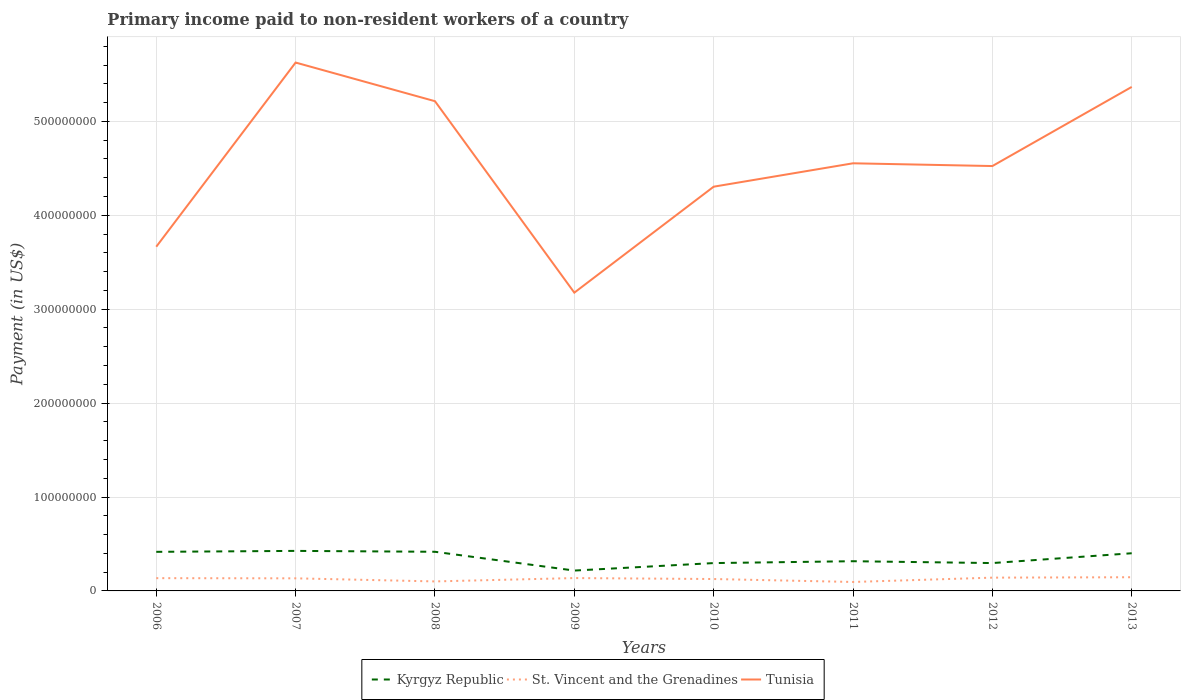How many different coloured lines are there?
Keep it short and to the point. 3. Is the number of lines equal to the number of legend labels?
Your answer should be very brief. Yes. Across all years, what is the maximum amount paid to workers in Tunisia?
Keep it short and to the point. 3.18e+08. What is the total amount paid to workers in Kyrgyz Republic in the graph?
Offer a very short reply. -1.44e+04. What is the difference between the highest and the second highest amount paid to workers in St. Vincent and the Grenadines?
Provide a short and direct response. 5.05e+06. Is the amount paid to workers in Tunisia strictly greater than the amount paid to workers in Kyrgyz Republic over the years?
Offer a terse response. No. How many lines are there?
Ensure brevity in your answer.  3. How many years are there in the graph?
Provide a short and direct response. 8. Are the values on the major ticks of Y-axis written in scientific E-notation?
Provide a succinct answer. No. Does the graph contain any zero values?
Your answer should be very brief. No. Does the graph contain grids?
Your answer should be compact. Yes. What is the title of the graph?
Provide a succinct answer. Primary income paid to non-resident workers of a country. What is the label or title of the Y-axis?
Your response must be concise. Payment (in US$). What is the Payment (in US$) in Kyrgyz Republic in 2006?
Your answer should be compact. 4.16e+07. What is the Payment (in US$) of St. Vincent and the Grenadines in 2006?
Provide a succinct answer. 1.36e+07. What is the Payment (in US$) of Tunisia in 2006?
Ensure brevity in your answer.  3.67e+08. What is the Payment (in US$) in Kyrgyz Republic in 2007?
Ensure brevity in your answer.  4.26e+07. What is the Payment (in US$) in St. Vincent and the Grenadines in 2007?
Make the answer very short. 1.34e+07. What is the Payment (in US$) in Tunisia in 2007?
Keep it short and to the point. 5.63e+08. What is the Payment (in US$) in Kyrgyz Republic in 2008?
Offer a very short reply. 4.17e+07. What is the Payment (in US$) in St. Vincent and the Grenadines in 2008?
Offer a very short reply. 1.01e+07. What is the Payment (in US$) in Tunisia in 2008?
Offer a very short reply. 5.22e+08. What is the Payment (in US$) of Kyrgyz Republic in 2009?
Keep it short and to the point. 2.17e+07. What is the Payment (in US$) of St. Vincent and the Grenadines in 2009?
Provide a succinct answer. 1.37e+07. What is the Payment (in US$) in Tunisia in 2009?
Make the answer very short. 3.18e+08. What is the Payment (in US$) of Kyrgyz Republic in 2010?
Your answer should be very brief. 2.97e+07. What is the Payment (in US$) of St. Vincent and the Grenadines in 2010?
Your response must be concise. 1.27e+07. What is the Payment (in US$) of Tunisia in 2010?
Your response must be concise. 4.30e+08. What is the Payment (in US$) of Kyrgyz Republic in 2011?
Your answer should be very brief. 3.16e+07. What is the Payment (in US$) in St. Vincent and the Grenadines in 2011?
Offer a very short reply. 9.53e+06. What is the Payment (in US$) of Tunisia in 2011?
Offer a terse response. 4.55e+08. What is the Payment (in US$) of Kyrgyz Republic in 2012?
Provide a succinct answer. 2.97e+07. What is the Payment (in US$) in St. Vincent and the Grenadines in 2012?
Give a very brief answer. 1.41e+07. What is the Payment (in US$) of Tunisia in 2012?
Offer a terse response. 4.52e+08. What is the Payment (in US$) in Kyrgyz Republic in 2013?
Your answer should be compact. 4.01e+07. What is the Payment (in US$) in St. Vincent and the Grenadines in 2013?
Your response must be concise. 1.46e+07. What is the Payment (in US$) in Tunisia in 2013?
Make the answer very short. 5.37e+08. Across all years, what is the maximum Payment (in US$) in Kyrgyz Republic?
Offer a terse response. 4.26e+07. Across all years, what is the maximum Payment (in US$) in St. Vincent and the Grenadines?
Your response must be concise. 1.46e+07. Across all years, what is the maximum Payment (in US$) in Tunisia?
Provide a short and direct response. 5.63e+08. Across all years, what is the minimum Payment (in US$) of Kyrgyz Republic?
Your response must be concise. 2.17e+07. Across all years, what is the minimum Payment (in US$) in St. Vincent and the Grenadines?
Your response must be concise. 9.53e+06. Across all years, what is the minimum Payment (in US$) of Tunisia?
Your response must be concise. 3.18e+08. What is the total Payment (in US$) of Kyrgyz Republic in the graph?
Provide a succinct answer. 2.79e+08. What is the total Payment (in US$) in St. Vincent and the Grenadines in the graph?
Offer a very short reply. 1.02e+08. What is the total Payment (in US$) in Tunisia in the graph?
Your answer should be compact. 3.64e+09. What is the difference between the Payment (in US$) in Kyrgyz Republic in 2006 and that in 2007?
Keep it short and to the point. -1.00e+06. What is the difference between the Payment (in US$) in St. Vincent and the Grenadines in 2006 and that in 2007?
Ensure brevity in your answer.  1.92e+05. What is the difference between the Payment (in US$) of Tunisia in 2006 and that in 2007?
Give a very brief answer. -1.96e+08. What is the difference between the Payment (in US$) in Kyrgyz Republic in 2006 and that in 2008?
Provide a succinct answer. -6.58e+04. What is the difference between the Payment (in US$) in St. Vincent and the Grenadines in 2006 and that in 2008?
Your answer should be very brief. 3.48e+06. What is the difference between the Payment (in US$) of Tunisia in 2006 and that in 2008?
Give a very brief answer. -1.55e+08. What is the difference between the Payment (in US$) in Kyrgyz Republic in 2006 and that in 2009?
Provide a succinct answer. 1.99e+07. What is the difference between the Payment (in US$) of St. Vincent and the Grenadines in 2006 and that in 2009?
Make the answer very short. -8.47e+04. What is the difference between the Payment (in US$) in Tunisia in 2006 and that in 2009?
Give a very brief answer. 4.89e+07. What is the difference between the Payment (in US$) of Kyrgyz Republic in 2006 and that in 2010?
Your answer should be compact. 1.20e+07. What is the difference between the Payment (in US$) of St. Vincent and the Grenadines in 2006 and that in 2010?
Give a very brief answer. 9.29e+05. What is the difference between the Payment (in US$) of Tunisia in 2006 and that in 2010?
Offer a terse response. -6.39e+07. What is the difference between the Payment (in US$) in Kyrgyz Republic in 2006 and that in 2011?
Offer a terse response. 9.99e+06. What is the difference between the Payment (in US$) of St. Vincent and the Grenadines in 2006 and that in 2011?
Offer a very short reply. 4.07e+06. What is the difference between the Payment (in US$) of Tunisia in 2006 and that in 2011?
Your response must be concise. -8.88e+07. What is the difference between the Payment (in US$) of Kyrgyz Republic in 2006 and that in 2012?
Keep it short and to the point. 1.20e+07. What is the difference between the Payment (in US$) of St. Vincent and the Grenadines in 2006 and that in 2012?
Your answer should be compact. -5.43e+05. What is the difference between the Payment (in US$) of Tunisia in 2006 and that in 2012?
Keep it short and to the point. -8.59e+07. What is the difference between the Payment (in US$) in Kyrgyz Republic in 2006 and that in 2013?
Make the answer very short. 1.51e+06. What is the difference between the Payment (in US$) of St. Vincent and the Grenadines in 2006 and that in 2013?
Provide a short and direct response. -9.82e+05. What is the difference between the Payment (in US$) in Tunisia in 2006 and that in 2013?
Your answer should be very brief. -1.70e+08. What is the difference between the Payment (in US$) in Kyrgyz Republic in 2007 and that in 2008?
Your answer should be compact. 9.36e+05. What is the difference between the Payment (in US$) of St. Vincent and the Grenadines in 2007 and that in 2008?
Ensure brevity in your answer.  3.29e+06. What is the difference between the Payment (in US$) in Tunisia in 2007 and that in 2008?
Make the answer very short. 4.12e+07. What is the difference between the Payment (in US$) of Kyrgyz Republic in 2007 and that in 2009?
Offer a very short reply. 2.09e+07. What is the difference between the Payment (in US$) in St. Vincent and the Grenadines in 2007 and that in 2009?
Give a very brief answer. -2.77e+05. What is the difference between the Payment (in US$) in Tunisia in 2007 and that in 2009?
Provide a succinct answer. 2.45e+08. What is the difference between the Payment (in US$) of Kyrgyz Republic in 2007 and that in 2010?
Provide a succinct answer. 1.30e+07. What is the difference between the Payment (in US$) of St. Vincent and the Grenadines in 2007 and that in 2010?
Make the answer very short. 7.36e+05. What is the difference between the Payment (in US$) in Tunisia in 2007 and that in 2010?
Keep it short and to the point. 1.32e+08. What is the difference between the Payment (in US$) in Kyrgyz Republic in 2007 and that in 2011?
Your answer should be compact. 1.10e+07. What is the difference between the Payment (in US$) in St. Vincent and the Grenadines in 2007 and that in 2011?
Your answer should be very brief. 3.88e+06. What is the difference between the Payment (in US$) in Tunisia in 2007 and that in 2011?
Offer a very short reply. 1.07e+08. What is the difference between the Payment (in US$) in Kyrgyz Republic in 2007 and that in 2012?
Provide a succinct answer. 1.30e+07. What is the difference between the Payment (in US$) in St. Vincent and the Grenadines in 2007 and that in 2012?
Your response must be concise. -7.35e+05. What is the difference between the Payment (in US$) of Tunisia in 2007 and that in 2012?
Your response must be concise. 1.10e+08. What is the difference between the Payment (in US$) of Kyrgyz Republic in 2007 and that in 2013?
Your response must be concise. 2.51e+06. What is the difference between the Payment (in US$) of St. Vincent and the Grenadines in 2007 and that in 2013?
Your answer should be compact. -1.17e+06. What is the difference between the Payment (in US$) in Tunisia in 2007 and that in 2013?
Give a very brief answer. 2.60e+07. What is the difference between the Payment (in US$) of Kyrgyz Republic in 2008 and that in 2009?
Your response must be concise. 2.00e+07. What is the difference between the Payment (in US$) of St. Vincent and the Grenadines in 2008 and that in 2009?
Provide a succinct answer. -3.57e+06. What is the difference between the Payment (in US$) of Tunisia in 2008 and that in 2009?
Your answer should be very brief. 2.04e+08. What is the difference between the Payment (in US$) in Kyrgyz Republic in 2008 and that in 2010?
Your answer should be very brief. 1.20e+07. What is the difference between the Payment (in US$) of St. Vincent and the Grenadines in 2008 and that in 2010?
Give a very brief answer. -2.55e+06. What is the difference between the Payment (in US$) of Tunisia in 2008 and that in 2010?
Offer a terse response. 9.10e+07. What is the difference between the Payment (in US$) in Kyrgyz Republic in 2008 and that in 2011?
Your answer should be compact. 1.01e+07. What is the difference between the Payment (in US$) in St. Vincent and the Grenadines in 2008 and that in 2011?
Your answer should be compact. 5.87e+05. What is the difference between the Payment (in US$) of Tunisia in 2008 and that in 2011?
Provide a succinct answer. 6.61e+07. What is the difference between the Payment (in US$) of Kyrgyz Republic in 2008 and that in 2012?
Provide a short and direct response. 1.20e+07. What is the difference between the Payment (in US$) of St. Vincent and the Grenadines in 2008 and that in 2012?
Provide a short and direct response. -4.03e+06. What is the difference between the Payment (in US$) of Tunisia in 2008 and that in 2012?
Your answer should be very brief. 6.91e+07. What is the difference between the Payment (in US$) in Kyrgyz Republic in 2008 and that in 2013?
Offer a very short reply. 1.58e+06. What is the difference between the Payment (in US$) in St. Vincent and the Grenadines in 2008 and that in 2013?
Offer a very short reply. -4.47e+06. What is the difference between the Payment (in US$) of Tunisia in 2008 and that in 2013?
Give a very brief answer. -1.52e+07. What is the difference between the Payment (in US$) in Kyrgyz Republic in 2009 and that in 2010?
Your answer should be very brief. -7.97e+06. What is the difference between the Payment (in US$) in St. Vincent and the Grenadines in 2009 and that in 2010?
Ensure brevity in your answer.  1.01e+06. What is the difference between the Payment (in US$) of Tunisia in 2009 and that in 2010?
Keep it short and to the point. -1.13e+08. What is the difference between the Payment (in US$) of Kyrgyz Republic in 2009 and that in 2011?
Give a very brief answer. -9.95e+06. What is the difference between the Payment (in US$) of St. Vincent and the Grenadines in 2009 and that in 2011?
Give a very brief answer. 4.16e+06. What is the difference between the Payment (in US$) in Tunisia in 2009 and that in 2011?
Your answer should be very brief. -1.38e+08. What is the difference between the Payment (in US$) in Kyrgyz Republic in 2009 and that in 2012?
Your answer should be compact. -7.99e+06. What is the difference between the Payment (in US$) in St. Vincent and the Grenadines in 2009 and that in 2012?
Your response must be concise. -4.58e+05. What is the difference between the Payment (in US$) in Tunisia in 2009 and that in 2012?
Provide a short and direct response. -1.35e+08. What is the difference between the Payment (in US$) in Kyrgyz Republic in 2009 and that in 2013?
Keep it short and to the point. -1.84e+07. What is the difference between the Payment (in US$) in St. Vincent and the Grenadines in 2009 and that in 2013?
Your answer should be compact. -8.98e+05. What is the difference between the Payment (in US$) of Tunisia in 2009 and that in 2013?
Your response must be concise. -2.19e+08. What is the difference between the Payment (in US$) of Kyrgyz Republic in 2010 and that in 2011?
Keep it short and to the point. -1.98e+06. What is the difference between the Payment (in US$) in St. Vincent and the Grenadines in 2010 and that in 2011?
Provide a succinct answer. 3.14e+06. What is the difference between the Payment (in US$) of Tunisia in 2010 and that in 2011?
Offer a very short reply. -2.49e+07. What is the difference between the Payment (in US$) in Kyrgyz Republic in 2010 and that in 2012?
Give a very brief answer. -1.44e+04. What is the difference between the Payment (in US$) of St. Vincent and the Grenadines in 2010 and that in 2012?
Give a very brief answer. -1.47e+06. What is the difference between the Payment (in US$) in Tunisia in 2010 and that in 2012?
Provide a succinct answer. -2.20e+07. What is the difference between the Payment (in US$) in Kyrgyz Republic in 2010 and that in 2013?
Your answer should be compact. -1.05e+07. What is the difference between the Payment (in US$) of St. Vincent and the Grenadines in 2010 and that in 2013?
Ensure brevity in your answer.  -1.91e+06. What is the difference between the Payment (in US$) of Tunisia in 2010 and that in 2013?
Provide a succinct answer. -1.06e+08. What is the difference between the Payment (in US$) in Kyrgyz Republic in 2011 and that in 2012?
Offer a very short reply. 1.96e+06. What is the difference between the Payment (in US$) of St. Vincent and the Grenadines in 2011 and that in 2012?
Give a very brief answer. -4.61e+06. What is the difference between the Payment (in US$) in Tunisia in 2011 and that in 2012?
Your response must be concise. 2.93e+06. What is the difference between the Payment (in US$) of Kyrgyz Republic in 2011 and that in 2013?
Make the answer very short. -8.48e+06. What is the difference between the Payment (in US$) in St. Vincent and the Grenadines in 2011 and that in 2013?
Provide a short and direct response. -5.05e+06. What is the difference between the Payment (in US$) of Tunisia in 2011 and that in 2013?
Your answer should be very brief. -8.13e+07. What is the difference between the Payment (in US$) in Kyrgyz Republic in 2012 and that in 2013?
Make the answer very short. -1.04e+07. What is the difference between the Payment (in US$) of St. Vincent and the Grenadines in 2012 and that in 2013?
Your answer should be compact. -4.39e+05. What is the difference between the Payment (in US$) of Tunisia in 2012 and that in 2013?
Your answer should be very brief. -8.43e+07. What is the difference between the Payment (in US$) of Kyrgyz Republic in 2006 and the Payment (in US$) of St. Vincent and the Grenadines in 2007?
Provide a short and direct response. 2.82e+07. What is the difference between the Payment (in US$) of Kyrgyz Republic in 2006 and the Payment (in US$) of Tunisia in 2007?
Make the answer very short. -5.21e+08. What is the difference between the Payment (in US$) of St. Vincent and the Grenadines in 2006 and the Payment (in US$) of Tunisia in 2007?
Offer a very short reply. -5.49e+08. What is the difference between the Payment (in US$) in Kyrgyz Republic in 2006 and the Payment (in US$) in St. Vincent and the Grenadines in 2008?
Make the answer very short. 3.15e+07. What is the difference between the Payment (in US$) in Kyrgyz Republic in 2006 and the Payment (in US$) in Tunisia in 2008?
Your answer should be compact. -4.80e+08. What is the difference between the Payment (in US$) of St. Vincent and the Grenadines in 2006 and the Payment (in US$) of Tunisia in 2008?
Keep it short and to the point. -5.08e+08. What is the difference between the Payment (in US$) in Kyrgyz Republic in 2006 and the Payment (in US$) in St. Vincent and the Grenadines in 2009?
Your response must be concise. 2.79e+07. What is the difference between the Payment (in US$) of Kyrgyz Republic in 2006 and the Payment (in US$) of Tunisia in 2009?
Give a very brief answer. -2.76e+08. What is the difference between the Payment (in US$) in St. Vincent and the Grenadines in 2006 and the Payment (in US$) in Tunisia in 2009?
Offer a terse response. -3.04e+08. What is the difference between the Payment (in US$) of Kyrgyz Republic in 2006 and the Payment (in US$) of St. Vincent and the Grenadines in 2010?
Your response must be concise. 2.90e+07. What is the difference between the Payment (in US$) in Kyrgyz Republic in 2006 and the Payment (in US$) in Tunisia in 2010?
Give a very brief answer. -3.89e+08. What is the difference between the Payment (in US$) of St. Vincent and the Grenadines in 2006 and the Payment (in US$) of Tunisia in 2010?
Ensure brevity in your answer.  -4.17e+08. What is the difference between the Payment (in US$) of Kyrgyz Republic in 2006 and the Payment (in US$) of St. Vincent and the Grenadines in 2011?
Your answer should be very brief. 3.21e+07. What is the difference between the Payment (in US$) of Kyrgyz Republic in 2006 and the Payment (in US$) of Tunisia in 2011?
Provide a succinct answer. -4.14e+08. What is the difference between the Payment (in US$) of St. Vincent and the Grenadines in 2006 and the Payment (in US$) of Tunisia in 2011?
Your answer should be very brief. -4.42e+08. What is the difference between the Payment (in US$) of Kyrgyz Republic in 2006 and the Payment (in US$) of St. Vincent and the Grenadines in 2012?
Your response must be concise. 2.75e+07. What is the difference between the Payment (in US$) in Kyrgyz Republic in 2006 and the Payment (in US$) in Tunisia in 2012?
Provide a short and direct response. -4.11e+08. What is the difference between the Payment (in US$) in St. Vincent and the Grenadines in 2006 and the Payment (in US$) in Tunisia in 2012?
Offer a terse response. -4.39e+08. What is the difference between the Payment (in US$) in Kyrgyz Republic in 2006 and the Payment (in US$) in St. Vincent and the Grenadines in 2013?
Offer a very short reply. 2.70e+07. What is the difference between the Payment (in US$) in Kyrgyz Republic in 2006 and the Payment (in US$) in Tunisia in 2013?
Give a very brief answer. -4.95e+08. What is the difference between the Payment (in US$) of St. Vincent and the Grenadines in 2006 and the Payment (in US$) of Tunisia in 2013?
Your answer should be compact. -5.23e+08. What is the difference between the Payment (in US$) of Kyrgyz Republic in 2007 and the Payment (in US$) of St. Vincent and the Grenadines in 2008?
Provide a succinct answer. 3.25e+07. What is the difference between the Payment (in US$) in Kyrgyz Republic in 2007 and the Payment (in US$) in Tunisia in 2008?
Provide a succinct answer. -4.79e+08. What is the difference between the Payment (in US$) in St. Vincent and the Grenadines in 2007 and the Payment (in US$) in Tunisia in 2008?
Your answer should be very brief. -5.08e+08. What is the difference between the Payment (in US$) of Kyrgyz Republic in 2007 and the Payment (in US$) of St. Vincent and the Grenadines in 2009?
Offer a terse response. 2.89e+07. What is the difference between the Payment (in US$) in Kyrgyz Republic in 2007 and the Payment (in US$) in Tunisia in 2009?
Provide a short and direct response. -2.75e+08. What is the difference between the Payment (in US$) in St. Vincent and the Grenadines in 2007 and the Payment (in US$) in Tunisia in 2009?
Provide a short and direct response. -3.04e+08. What is the difference between the Payment (in US$) of Kyrgyz Republic in 2007 and the Payment (in US$) of St. Vincent and the Grenadines in 2010?
Your answer should be compact. 3.00e+07. What is the difference between the Payment (in US$) in Kyrgyz Republic in 2007 and the Payment (in US$) in Tunisia in 2010?
Ensure brevity in your answer.  -3.88e+08. What is the difference between the Payment (in US$) in St. Vincent and the Grenadines in 2007 and the Payment (in US$) in Tunisia in 2010?
Your answer should be compact. -4.17e+08. What is the difference between the Payment (in US$) in Kyrgyz Republic in 2007 and the Payment (in US$) in St. Vincent and the Grenadines in 2011?
Your answer should be compact. 3.31e+07. What is the difference between the Payment (in US$) in Kyrgyz Republic in 2007 and the Payment (in US$) in Tunisia in 2011?
Give a very brief answer. -4.13e+08. What is the difference between the Payment (in US$) in St. Vincent and the Grenadines in 2007 and the Payment (in US$) in Tunisia in 2011?
Provide a succinct answer. -4.42e+08. What is the difference between the Payment (in US$) of Kyrgyz Republic in 2007 and the Payment (in US$) of St. Vincent and the Grenadines in 2012?
Ensure brevity in your answer.  2.85e+07. What is the difference between the Payment (in US$) of Kyrgyz Republic in 2007 and the Payment (in US$) of Tunisia in 2012?
Your answer should be compact. -4.10e+08. What is the difference between the Payment (in US$) in St. Vincent and the Grenadines in 2007 and the Payment (in US$) in Tunisia in 2012?
Keep it short and to the point. -4.39e+08. What is the difference between the Payment (in US$) in Kyrgyz Republic in 2007 and the Payment (in US$) in St. Vincent and the Grenadines in 2013?
Your answer should be very brief. 2.80e+07. What is the difference between the Payment (in US$) in Kyrgyz Republic in 2007 and the Payment (in US$) in Tunisia in 2013?
Your answer should be compact. -4.94e+08. What is the difference between the Payment (in US$) of St. Vincent and the Grenadines in 2007 and the Payment (in US$) of Tunisia in 2013?
Your answer should be very brief. -5.23e+08. What is the difference between the Payment (in US$) in Kyrgyz Republic in 2008 and the Payment (in US$) in St. Vincent and the Grenadines in 2009?
Offer a very short reply. 2.80e+07. What is the difference between the Payment (in US$) in Kyrgyz Republic in 2008 and the Payment (in US$) in Tunisia in 2009?
Offer a terse response. -2.76e+08. What is the difference between the Payment (in US$) in St. Vincent and the Grenadines in 2008 and the Payment (in US$) in Tunisia in 2009?
Your response must be concise. -3.08e+08. What is the difference between the Payment (in US$) of Kyrgyz Republic in 2008 and the Payment (in US$) of St. Vincent and the Grenadines in 2010?
Ensure brevity in your answer.  2.90e+07. What is the difference between the Payment (in US$) of Kyrgyz Republic in 2008 and the Payment (in US$) of Tunisia in 2010?
Provide a short and direct response. -3.89e+08. What is the difference between the Payment (in US$) of St. Vincent and the Grenadines in 2008 and the Payment (in US$) of Tunisia in 2010?
Give a very brief answer. -4.20e+08. What is the difference between the Payment (in US$) of Kyrgyz Republic in 2008 and the Payment (in US$) of St. Vincent and the Grenadines in 2011?
Give a very brief answer. 3.22e+07. What is the difference between the Payment (in US$) in Kyrgyz Republic in 2008 and the Payment (in US$) in Tunisia in 2011?
Your response must be concise. -4.14e+08. What is the difference between the Payment (in US$) in St. Vincent and the Grenadines in 2008 and the Payment (in US$) in Tunisia in 2011?
Offer a very short reply. -4.45e+08. What is the difference between the Payment (in US$) of Kyrgyz Republic in 2008 and the Payment (in US$) of St. Vincent and the Grenadines in 2012?
Keep it short and to the point. 2.75e+07. What is the difference between the Payment (in US$) in Kyrgyz Republic in 2008 and the Payment (in US$) in Tunisia in 2012?
Give a very brief answer. -4.11e+08. What is the difference between the Payment (in US$) in St. Vincent and the Grenadines in 2008 and the Payment (in US$) in Tunisia in 2012?
Offer a terse response. -4.42e+08. What is the difference between the Payment (in US$) in Kyrgyz Republic in 2008 and the Payment (in US$) in St. Vincent and the Grenadines in 2013?
Offer a very short reply. 2.71e+07. What is the difference between the Payment (in US$) of Kyrgyz Republic in 2008 and the Payment (in US$) of Tunisia in 2013?
Your response must be concise. -4.95e+08. What is the difference between the Payment (in US$) in St. Vincent and the Grenadines in 2008 and the Payment (in US$) in Tunisia in 2013?
Your answer should be very brief. -5.27e+08. What is the difference between the Payment (in US$) of Kyrgyz Republic in 2009 and the Payment (in US$) of St. Vincent and the Grenadines in 2010?
Your answer should be very brief. 9.01e+06. What is the difference between the Payment (in US$) in Kyrgyz Republic in 2009 and the Payment (in US$) in Tunisia in 2010?
Your answer should be compact. -4.09e+08. What is the difference between the Payment (in US$) in St. Vincent and the Grenadines in 2009 and the Payment (in US$) in Tunisia in 2010?
Make the answer very short. -4.17e+08. What is the difference between the Payment (in US$) of Kyrgyz Republic in 2009 and the Payment (in US$) of St. Vincent and the Grenadines in 2011?
Ensure brevity in your answer.  1.22e+07. What is the difference between the Payment (in US$) of Kyrgyz Republic in 2009 and the Payment (in US$) of Tunisia in 2011?
Your answer should be compact. -4.34e+08. What is the difference between the Payment (in US$) of St. Vincent and the Grenadines in 2009 and the Payment (in US$) of Tunisia in 2011?
Ensure brevity in your answer.  -4.42e+08. What is the difference between the Payment (in US$) of Kyrgyz Republic in 2009 and the Payment (in US$) of St. Vincent and the Grenadines in 2012?
Provide a succinct answer. 7.54e+06. What is the difference between the Payment (in US$) of Kyrgyz Republic in 2009 and the Payment (in US$) of Tunisia in 2012?
Give a very brief answer. -4.31e+08. What is the difference between the Payment (in US$) in St. Vincent and the Grenadines in 2009 and the Payment (in US$) in Tunisia in 2012?
Give a very brief answer. -4.39e+08. What is the difference between the Payment (in US$) of Kyrgyz Republic in 2009 and the Payment (in US$) of St. Vincent and the Grenadines in 2013?
Keep it short and to the point. 7.10e+06. What is the difference between the Payment (in US$) in Kyrgyz Republic in 2009 and the Payment (in US$) in Tunisia in 2013?
Offer a very short reply. -5.15e+08. What is the difference between the Payment (in US$) in St. Vincent and the Grenadines in 2009 and the Payment (in US$) in Tunisia in 2013?
Keep it short and to the point. -5.23e+08. What is the difference between the Payment (in US$) in Kyrgyz Republic in 2010 and the Payment (in US$) in St. Vincent and the Grenadines in 2011?
Your response must be concise. 2.01e+07. What is the difference between the Payment (in US$) in Kyrgyz Republic in 2010 and the Payment (in US$) in Tunisia in 2011?
Provide a short and direct response. -4.26e+08. What is the difference between the Payment (in US$) of St. Vincent and the Grenadines in 2010 and the Payment (in US$) of Tunisia in 2011?
Provide a short and direct response. -4.43e+08. What is the difference between the Payment (in US$) in Kyrgyz Republic in 2010 and the Payment (in US$) in St. Vincent and the Grenadines in 2012?
Provide a short and direct response. 1.55e+07. What is the difference between the Payment (in US$) in Kyrgyz Republic in 2010 and the Payment (in US$) in Tunisia in 2012?
Make the answer very short. -4.23e+08. What is the difference between the Payment (in US$) in St. Vincent and the Grenadines in 2010 and the Payment (in US$) in Tunisia in 2012?
Provide a succinct answer. -4.40e+08. What is the difference between the Payment (in US$) in Kyrgyz Republic in 2010 and the Payment (in US$) in St. Vincent and the Grenadines in 2013?
Your response must be concise. 1.51e+07. What is the difference between the Payment (in US$) in Kyrgyz Republic in 2010 and the Payment (in US$) in Tunisia in 2013?
Provide a short and direct response. -5.07e+08. What is the difference between the Payment (in US$) of St. Vincent and the Grenadines in 2010 and the Payment (in US$) of Tunisia in 2013?
Your answer should be very brief. -5.24e+08. What is the difference between the Payment (in US$) of Kyrgyz Republic in 2011 and the Payment (in US$) of St. Vincent and the Grenadines in 2012?
Offer a very short reply. 1.75e+07. What is the difference between the Payment (in US$) in Kyrgyz Republic in 2011 and the Payment (in US$) in Tunisia in 2012?
Keep it short and to the point. -4.21e+08. What is the difference between the Payment (in US$) of St. Vincent and the Grenadines in 2011 and the Payment (in US$) of Tunisia in 2012?
Make the answer very short. -4.43e+08. What is the difference between the Payment (in US$) in Kyrgyz Republic in 2011 and the Payment (in US$) in St. Vincent and the Grenadines in 2013?
Provide a short and direct response. 1.70e+07. What is the difference between the Payment (in US$) of Kyrgyz Republic in 2011 and the Payment (in US$) of Tunisia in 2013?
Your answer should be compact. -5.05e+08. What is the difference between the Payment (in US$) in St. Vincent and the Grenadines in 2011 and the Payment (in US$) in Tunisia in 2013?
Your response must be concise. -5.27e+08. What is the difference between the Payment (in US$) in Kyrgyz Republic in 2012 and the Payment (in US$) in St. Vincent and the Grenadines in 2013?
Offer a terse response. 1.51e+07. What is the difference between the Payment (in US$) in Kyrgyz Republic in 2012 and the Payment (in US$) in Tunisia in 2013?
Give a very brief answer. -5.07e+08. What is the difference between the Payment (in US$) in St. Vincent and the Grenadines in 2012 and the Payment (in US$) in Tunisia in 2013?
Offer a terse response. -5.23e+08. What is the average Payment (in US$) in Kyrgyz Republic per year?
Provide a succinct answer. 3.48e+07. What is the average Payment (in US$) of St. Vincent and the Grenadines per year?
Provide a short and direct response. 1.27e+07. What is the average Payment (in US$) in Tunisia per year?
Make the answer very short. 4.55e+08. In the year 2006, what is the difference between the Payment (in US$) in Kyrgyz Republic and Payment (in US$) in St. Vincent and the Grenadines?
Provide a short and direct response. 2.80e+07. In the year 2006, what is the difference between the Payment (in US$) of Kyrgyz Republic and Payment (in US$) of Tunisia?
Your response must be concise. -3.25e+08. In the year 2006, what is the difference between the Payment (in US$) of St. Vincent and the Grenadines and Payment (in US$) of Tunisia?
Provide a short and direct response. -3.53e+08. In the year 2007, what is the difference between the Payment (in US$) of Kyrgyz Republic and Payment (in US$) of St. Vincent and the Grenadines?
Make the answer very short. 2.92e+07. In the year 2007, what is the difference between the Payment (in US$) of Kyrgyz Republic and Payment (in US$) of Tunisia?
Offer a very short reply. -5.20e+08. In the year 2007, what is the difference between the Payment (in US$) of St. Vincent and the Grenadines and Payment (in US$) of Tunisia?
Your response must be concise. -5.49e+08. In the year 2008, what is the difference between the Payment (in US$) in Kyrgyz Republic and Payment (in US$) in St. Vincent and the Grenadines?
Provide a succinct answer. 3.16e+07. In the year 2008, what is the difference between the Payment (in US$) in Kyrgyz Republic and Payment (in US$) in Tunisia?
Keep it short and to the point. -4.80e+08. In the year 2008, what is the difference between the Payment (in US$) in St. Vincent and the Grenadines and Payment (in US$) in Tunisia?
Your response must be concise. -5.11e+08. In the year 2009, what is the difference between the Payment (in US$) in Kyrgyz Republic and Payment (in US$) in St. Vincent and the Grenadines?
Your response must be concise. 8.00e+06. In the year 2009, what is the difference between the Payment (in US$) in Kyrgyz Republic and Payment (in US$) in Tunisia?
Your response must be concise. -2.96e+08. In the year 2009, what is the difference between the Payment (in US$) in St. Vincent and the Grenadines and Payment (in US$) in Tunisia?
Give a very brief answer. -3.04e+08. In the year 2010, what is the difference between the Payment (in US$) of Kyrgyz Republic and Payment (in US$) of St. Vincent and the Grenadines?
Offer a terse response. 1.70e+07. In the year 2010, what is the difference between the Payment (in US$) in Kyrgyz Republic and Payment (in US$) in Tunisia?
Offer a very short reply. -4.01e+08. In the year 2010, what is the difference between the Payment (in US$) in St. Vincent and the Grenadines and Payment (in US$) in Tunisia?
Your answer should be compact. -4.18e+08. In the year 2011, what is the difference between the Payment (in US$) of Kyrgyz Republic and Payment (in US$) of St. Vincent and the Grenadines?
Your response must be concise. 2.21e+07. In the year 2011, what is the difference between the Payment (in US$) of Kyrgyz Republic and Payment (in US$) of Tunisia?
Keep it short and to the point. -4.24e+08. In the year 2011, what is the difference between the Payment (in US$) in St. Vincent and the Grenadines and Payment (in US$) in Tunisia?
Provide a succinct answer. -4.46e+08. In the year 2012, what is the difference between the Payment (in US$) of Kyrgyz Republic and Payment (in US$) of St. Vincent and the Grenadines?
Provide a short and direct response. 1.55e+07. In the year 2012, what is the difference between the Payment (in US$) of Kyrgyz Republic and Payment (in US$) of Tunisia?
Offer a very short reply. -4.23e+08. In the year 2012, what is the difference between the Payment (in US$) of St. Vincent and the Grenadines and Payment (in US$) of Tunisia?
Offer a very short reply. -4.38e+08. In the year 2013, what is the difference between the Payment (in US$) of Kyrgyz Republic and Payment (in US$) of St. Vincent and the Grenadines?
Make the answer very short. 2.55e+07. In the year 2013, what is the difference between the Payment (in US$) in Kyrgyz Republic and Payment (in US$) in Tunisia?
Provide a succinct answer. -4.97e+08. In the year 2013, what is the difference between the Payment (in US$) in St. Vincent and the Grenadines and Payment (in US$) in Tunisia?
Keep it short and to the point. -5.22e+08. What is the ratio of the Payment (in US$) in Kyrgyz Republic in 2006 to that in 2007?
Offer a terse response. 0.98. What is the ratio of the Payment (in US$) in St. Vincent and the Grenadines in 2006 to that in 2007?
Your response must be concise. 1.01. What is the ratio of the Payment (in US$) of Tunisia in 2006 to that in 2007?
Your response must be concise. 0.65. What is the ratio of the Payment (in US$) of Kyrgyz Republic in 2006 to that in 2008?
Your response must be concise. 1. What is the ratio of the Payment (in US$) in St. Vincent and the Grenadines in 2006 to that in 2008?
Ensure brevity in your answer.  1.34. What is the ratio of the Payment (in US$) of Tunisia in 2006 to that in 2008?
Provide a succinct answer. 0.7. What is the ratio of the Payment (in US$) of Kyrgyz Republic in 2006 to that in 2009?
Provide a succinct answer. 1.92. What is the ratio of the Payment (in US$) in Tunisia in 2006 to that in 2009?
Ensure brevity in your answer.  1.15. What is the ratio of the Payment (in US$) in Kyrgyz Republic in 2006 to that in 2010?
Provide a succinct answer. 1.4. What is the ratio of the Payment (in US$) of St. Vincent and the Grenadines in 2006 to that in 2010?
Give a very brief answer. 1.07. What is the ratio of the Payment (in US$) in Tunisia in 2006 to that in 2010?
Give a very brief answer. 0.85. What is the ratio of the Payment (in US$) of Kyrgyz Republic in 2006 to that in 2011?
Make the answer very short. 1.32. What is the ratio of the Payment (in US$) in St. Vincent and the Grenadines in 2006 to that in 2011?
Give a very brief answer. 1.43. What is the ratio of the Payment (in US$) of Tunisia in 2006 to that in 2011?
Ensure brevity in your answer.  0.8. What is the ratio of the Payment (in US$) of Kyrgyz Republic in 2006 to that in 2012?
Provide a short and direct response. 1.4. What is the ratio of the Payment (in US$) in St. Vincent and the Grenadines in 2006 to that in 2012?
Ensure brevity in your answer.  0.96. What is the ratio of the Payment (in US$) of Tunisia in 2006 to that in 2012?
Offer a terse response. 0.81. What is the ratio of the Payment (in US$) of Kyrgyz Republic in 2006 to that in 2013?
Your answer should be compact. 1.04. What is the ratio of the Payment (in US$) of St. Vincent and the Grenadines in 2006 to that in 2013?
Provide a succinct answer. 0.93. What is the ratio of the Payment (in US$) of Tunisia in 2006 to that in 2013?
Keep it short and to the point. 0.68. What is the ratio of the Payment (in US$) of Kyrgyz Republic in 2007 to that in 2008?
Give a very brief answer. 1.02. What is the ratio of the Payment (in US$) in St. Vincent and the Grenadines in 2007 to that in 2008?
Your answer should be compact. 1.33. What is the ratio of the Payment (in US$) of Tunisia in 2007 to that in 2008?
Your response must be concise. 1.08. What is the ratio of the Payment (in US$) in Kyrgyz Republic in 2007 to that in 2009?
Offer a terse response. 1.97. What is the ratio of the Payment (in US$) in St. Vincent and the Grenadines in 2007 to that in 2009?
Your answer should be very brief. 0.98. What is the ratio of the Payment (in US$) in Tunisia in 2007 to that in 2009?
Make the answer very short. 1.77. What is the ratio of the Payment (in US$) of Kyrgyz Republic in 2007 to that in 2010?
Offer a terse response. 1.44. What is the ratio of the Payment (in US$) in St. Vincent and the Grenadines in 2007 to that in 2010?
Make the answer very short. 1.06. What is the ratio of the Payment (in US$) of Tunisia in 2007 to that in 2010?
Offer a very short reply. 1.31. What is the ratio of the Payment (in US$) of Kyrgyz Republic in 2007 to that in 2011?
Make the answer very short. 1.35. What is the ratio of the Payment (in US$) of St. Vincent and the Grenadines in 2007 to that in 2011?
Ensure brevity in your answer.  1.41. What is the ratio of the Payment (in US$) in Tunisia in 2007 to that in 2011?
Your answer should be compact. 1.24. What is the ratio of the Payment (in US$) in Kyrgyz Republic in 2007 to that in 2012?
Provide a short and direct response. 1.44. What is the ratio of the Payment (in US$) in St. Vincent and the Grenadines in 2007 to that in 2012?
Keep it short and to the point. 0.95. What is the ratio of the Payment (in US$) of Tunisia in 2007 to that in 2012?
Ensure brevity in your answer.  1.24. What is the ratio of the Payment (in US$) in Kyrgyz Republic in 2007 to that in 2013?
Your answer should be very brief. 1.06. What is the ratio of the Payment (in US$) in St. Vincent and the Grenadines in 2007 to that in 2013?
Your response must be concise. 0.92. What is the ratio of the Payment (in US$) of Tunisia in 2007 to that in 2013?
Provide a succinct answer. 1.05. What is the ratio of the Payment (in US$) in Kyrgyz Republic in 2008 to that in 2009?
Give a very brief answer. 1.92. What is the ratio of the Payment (in US$) in St. Vincent and the Grenadines in 2008 to that in 2009?
Your answer should be very brief. 0.74. What is the ratio of the Payment (in US$) of Tunisia in 2008 to that in 2009?
Make the answer very short. 1.64. What is the ratio of the Payment (in US$) in Kyrgyz Republic in 2008 to that in 2010?
Offer a very short reply. 1.41. What is the ratio of the Payment (in US$) of St. Vincent and the Grenadines in 2008 to that in 2010?
Offer a very short reply. 0.8. What is the ratio of the Payment (in US$) of Tunisia in 2008 to that in 2010?
Offer a very short reply. 1.21. What is the ratio of the Payment (in US$) in Kyrgyz Republic in 2008 to that in 2011?
Offer a terse response. 1.32. What is the ratio of the Payment (in US$) in St. Vincent and the Grenadines in 2008 to that in 2011?
Keep it short and to the point. 1.06. What is the ratio of the Payment (in US$) of Tunisia in 2008 to that in 2011?
Offer a very short reply. 1.15. What is the ratio of the Payment (in US$) of Kyrgyz Republic in 2008 to that in 2012?
Your answer should be compact. 1.41. What is the ratio of the Payment (in US$) in St. Vincent and the Grenadines in 2008 to that in 2012?
Ensure brevity in your answer.  0.72. What is the ratio of the Payment (in US$) in Tunisia in 2008 to that in 2012?
Offer a terse response. 1.15. What is the ratio of the Payment (in US$) of Kyrgyz Republic in 2008 to that in 2013?
Provide a succinct answer. 1.04. What is the ratio of the Payment (in US$) of St. Vincent and the Grenadines in 2008 to that in 2013?
Your response must be concise. 0.69. What is the ratio of the Payment (in US$) of Tunisia in 2008 to that in 2013?
Make the answer very short. 0.97. What is the ratio of the Payment (in US$) of Kyrgyz Republic in 2009 to that in 2010?
Offer a terse response. 0.73. What is the ratio of the Payment (in US$) of Tunisia in 2009 to that in 2010?
Keep it short and to the point. 0.74. What is the ratio of the Payment (in US$) of Kyrgyz Republic in 2009 to that in 2011?
Your answer should be very brief. 0.69. What is the ratio of the Payment (in US$) of St. Vincent and the Grenadines in 2009 to that in 2011?
Give a very brief answer. 1.44. What is the ratio of the Payment (in US$) of Tunisia in 2009 to that in 2011?
Provide a short and direct response. 0.7. What is the ratio of the Payment (in US$) of Kyrgyz Republic in 2009 to that in 2012?
Your answer should be very brief. 0.73. What is the ratio of the Payment (in US$) in St. Vincent and the Grenadines in 2009 to that in 2012?
Offer a terse response. 0.97. What is the ratio of the Payment (in US$) in Tunisia in 2009 to that in 2012?
Offer a very short reply. 0.7. What is the ratio of the Payment (in US$) of Kyrgyz Republic in 2009 to that in 2013?
Your answer should be very brief. 0.54. What is the ratio of the Payment (in US$) of St. Vincent and the Grenadines in 2009 to that in 2013?
Your answer should be very brief. 0.94. What is the ratio of the Payment (in US$) of Tunisia in 2009 to that in 2013?
Your response must be concise. 0.59. What is the ratio of the Payment (in US$) in Kyrgyz Republic in 2010 to that in 2011?
Give a very brief answer. 0.94. What is the ratio of the Payment (in US$) of St. Vincent and the Grenadines in 2010 to that in 2011?
Offer a very short reply. 1.33. What is the ratio of the Payment (in US$) in Tunisia in 2010 to that in 2011?
Keep it short and to the point. 0.95. What is the ratio of the Payment (in US$) of Kyrgyz Republic in 2010 to that in 2012?
Keep it short and to the point. 1. What is the ratio of the Payment (in US$) in St. Vincent and the Grenadines in 2010 to that in 2012?
Make the answer very short. 0.9. What is the ratio of the Payment (in US$) in Tunisia in 2010 to that in 2012?
Provide a succinct answer. 0.95. What is the ratio of the Payment (in US$) of Kyrgyz Republic in 2010 to that in 2013?
Give a very brief answer. 0.74. What is the ratio of the Payment (in US$) in St. Vincent and the Grenadines in 2010 to that in 2013?
Keep it short and to the point. 0.87. What is the ratio of the Payment (in US$) in Tunisia in 2010 to that in 2013?
Ensure brevity in your answer.  0.8. What is the ratio of the Payment (in US$) in Kyrgyz Republic in 2011 to that in 2012?
Keep it short and to the point. 1.07. What is the ratio of the Payment (in US$) in St. Vincent and the Grenadines in 2011 to that in 2012?
Offer a terse response. 0.67. What is the ratio of the Payment (in US$) in Kyrgyz Republic in 2011 to that in 2013?
Offer a very short reply. 0.79. What is the ratio of the Payment (in US$) in St. Vincent and the Grenadines in 2011 to that in 2013?
Provide a short and direct response. 0.65. What is the ratio of the Payment (in US$) of Tunisia in 2011 to that in 2013?
Provide a succinct answer. 0.85. What is the ratio of the Payment (in US$) in Kyrgyz Republic in 2012 to that in 2013?
Give a very brief answer. 0.74. What is the ratio of the Payment (in US$) in St. Vincent and the Grenadines in 2012 to that in 2013?
Make the answer very short. 0.97. What is the ratio of the Payment (in US$) in Tunisia in 2012 to that in 2013?
Provide a short and direct response. 0.84. What is the difference between the highest and the second highest Payment (in US$) of Kyrgyz Republic?
Give a very brief answer. 9.36e+05. What is the difference between the highest and the second highest Payment (in US$) of St. Vincent and the Grenadines?
Offer a terse response. 4.39e+05. What is the difference between the highest and the second highest Payment (in US$) in Tunisia?
Offer a very short reply. 2.60e+07. What is the difference between the highest and the lowest Payment (in US$) of Kyrgyz Republic?
Your answer should be compact. 2.09e+07. What is the difference between the highest and the lowest Payment (in US$) in St. Vincent and the Grenadines?
Your answer should be very brief. 5.05e+06. What is the difference between the highest and the lowest Payment (in US$) of Tunisia?
Ensure brevity in your answer.  2.45e+08. 